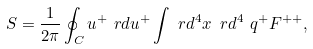<formula> <loc_0><loc_0><loc_500><loc_500>S & = \frac { 1 } { 2 \pi } \oint _ { C } u ^ { + } \ r d u ^ { + } \int \ r d ^ { 4 } x \, \ r d ^ { 4 } \ q ^ { + } F ^ { + + } ,</formula> 